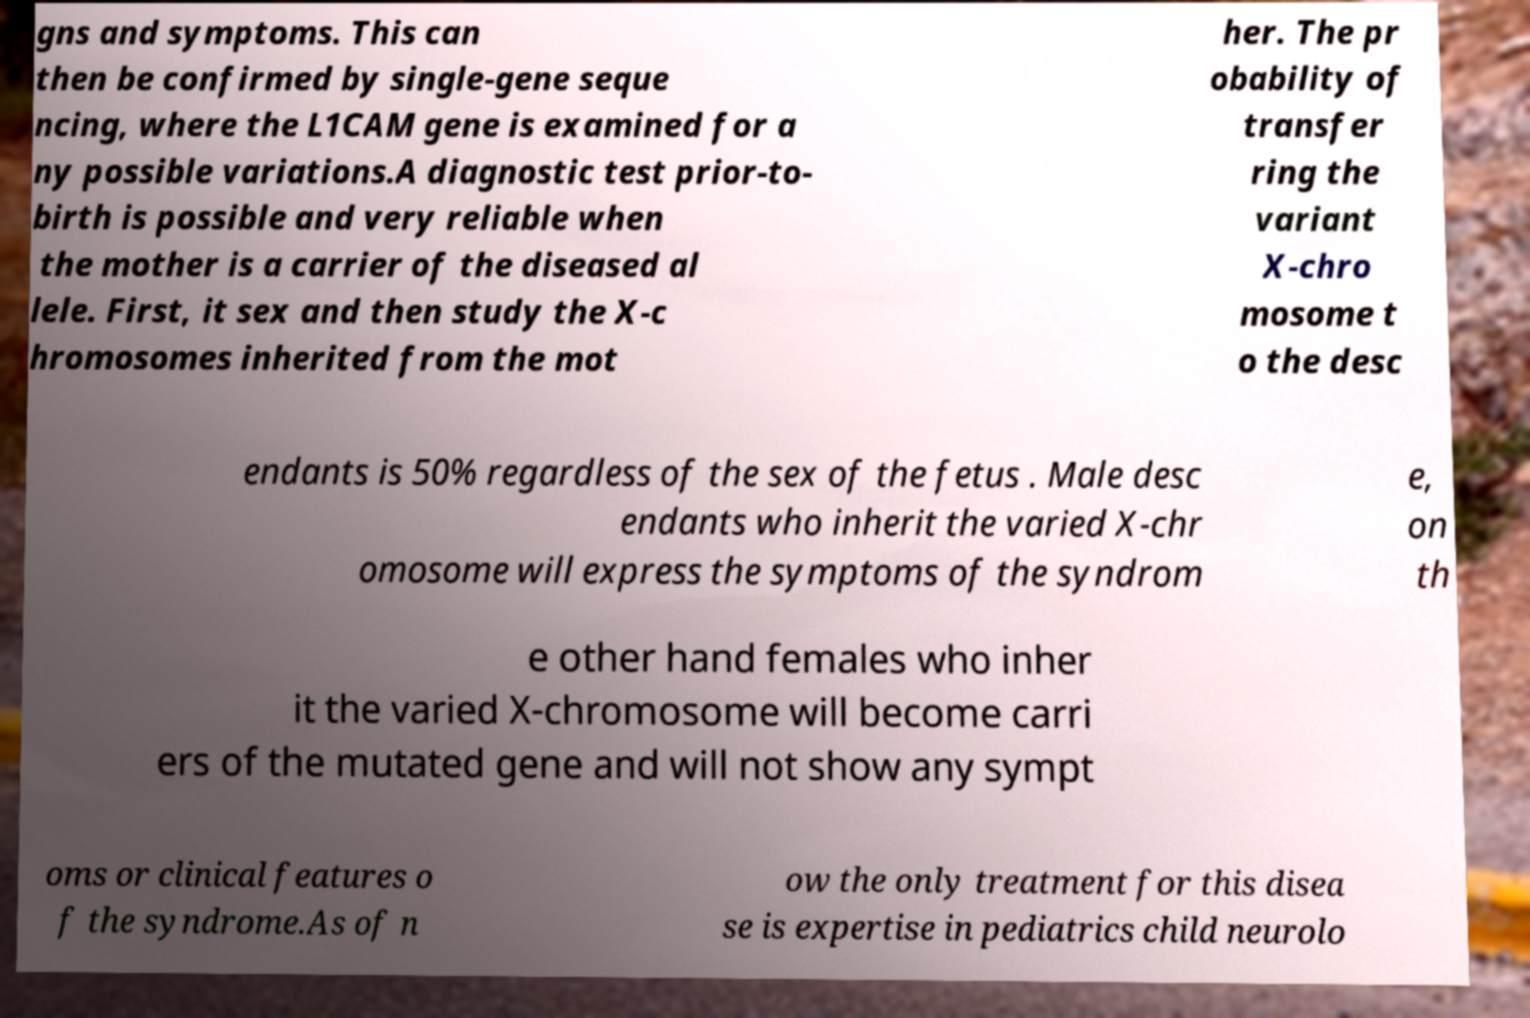Could you extract and type out the text from this image? gns and symptoms. This can then be confirmed by single-gene seque ncing, where the L1CAM gene is examined for a ny possible variations.A diagnostic test prior-to- birth is possible and very reliable when the mother is a carrier of the diseased al lele. First, it sex and then study the X-c hromosomes inherited from the mot her. The pr obability of transfer ring the variant X-chro mosome t o the desc endants is 50% regardless of the sex of the fetus . Male desc endants who inherit the varied X-chr omosome will express the symptoms of the syndrom e, on th e other hand females who inher it the varied X-chromosome will become carri ers of the mutated gene and will not show any sympt oms or clinical features o f the syndrome.As of n ow the only treatment for this disea se is expertise in pediatrics child neurolo 